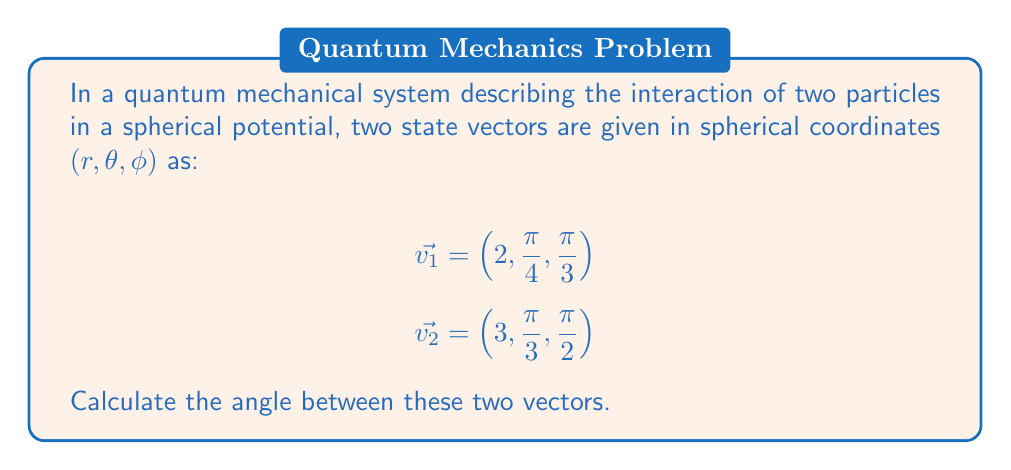Give your solution to this math problem. To find the angle between two vectors in spherical coordinates, we can use the dot product formula:

$$\cos \alpha = \frac{\vec{v_1} \cdot \vec{v_2}}{|\vec{v_1}||\vec{v_2}|}$$

In spherical coordinates, the dot product of two vectors $\vec{v_1} = (r_1, \theta_1, \phi_1)$ and $\vec{v_2} = (r_2, \theta_2, \phi_2)$ is given by:

$$\vec{v_1} \cdot \vec{v_2} = r_1r_2[\sin\theta_1\sin\theta_2\cos(\phi_1-\phi_2) + \cos\theta_1\cos\theta_2]$$

Let's calculate each component:

1) $r_1r_2 = 2 \cdot 3 = 6$

2) $\sin\theta_1\sin\theta_2 = \sin(\frac{\pi}{4})\sin(\frac{\pi}{3}) = \frac{\sqrt{2}}{2} \cdot \frac{\sqrt{3}}{2} = \frac{\sqrt{6}}{4}$

3) $\cos(\phi_1-\phi_2) = \cos(\frac{\pi}{3} - \frac{\pi}{2}) = \cos(-\frac{\pi}{6}) = \frac{\sqrt{3}}{2}$

4) $\cos\theta_1\cos\theta_2 = \cos(\frac{\pi}{4})\cos(\frac{\pi}{3}) = \frac{\sqrt{2}}{2} \cdot \frac{1}{2} = \frac{\sqrt{2}}{4}$

Putting it all together:

$$\vec{v_1} \cdot \vec{v_2} = 6[(\frac{\sqrt{6}}{4} \cdot \frac{\sqrt{3}}{2}) + \frac{\sqrt{2}}{4}] = 6[\frac{3\sqrt{2}}{4} + \frac{\sqrt{2}}{4}] = 6 \cdot \sqrt{2}$$

Now, we need to calculate the magnitudes of the vectors:

$$|\vec{v_1}| = 2, |\vec{v_2}| = 3$$

Finally, we can calculate the angle:

$$\cos \alpha = \frac{6\sqrt{2}}{2 \cdot 3} = \sqrt{2}$$

$$\alpha = \arccos(\sqrt{2})$$
Answer: The angle between the two vectors is $\alpha = \arccos(\sqrt{2}) \approx 0.7854$ radians or $45°$. 